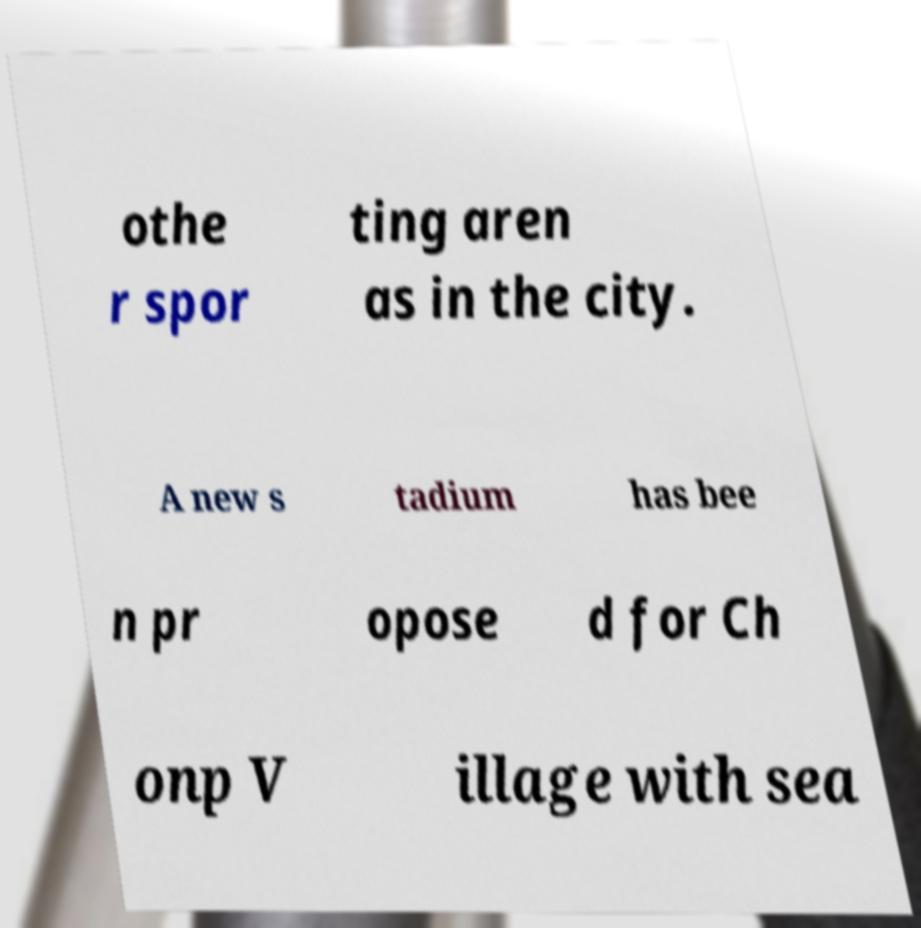Can you read and provide the text displayed in the image?This photo seems to have some interesting text. Can you extract and type it out for me? othe r spor ting aren as in the city. A new s tadium has bee n pr opose d for Ch onp V illage with sea 